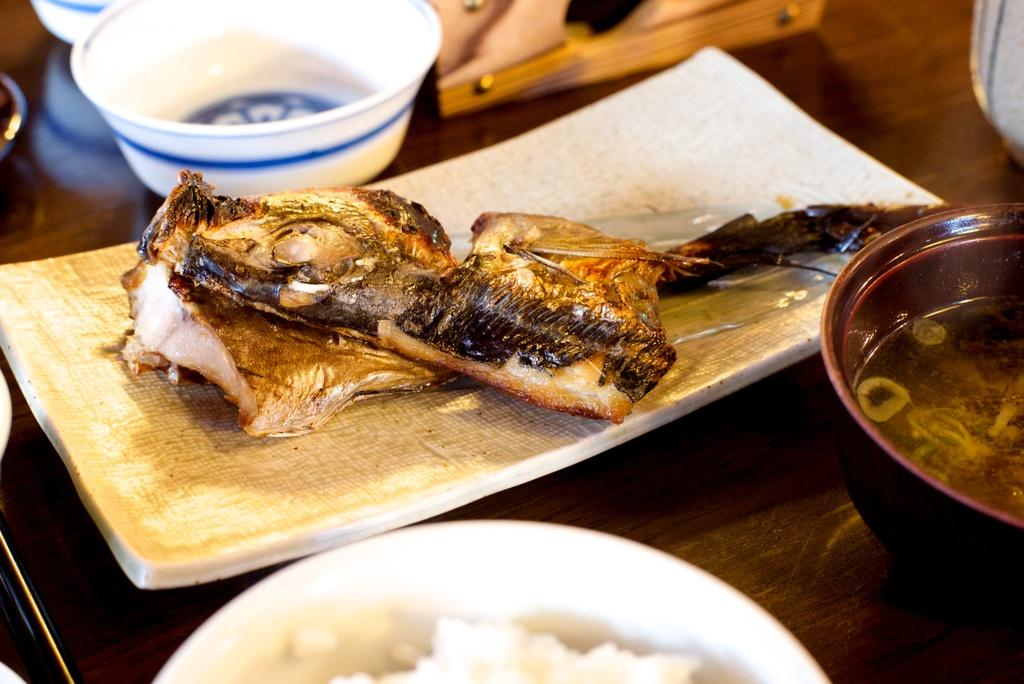What type of dishware can be seen in the image? There are bowls and a plate in the image. What can be found inside the bowls and on the plate? There are different types of food in the image. What type of pie is visible in the image? There is no pie present in the image; it only features bowls and a plate with different types of food. 